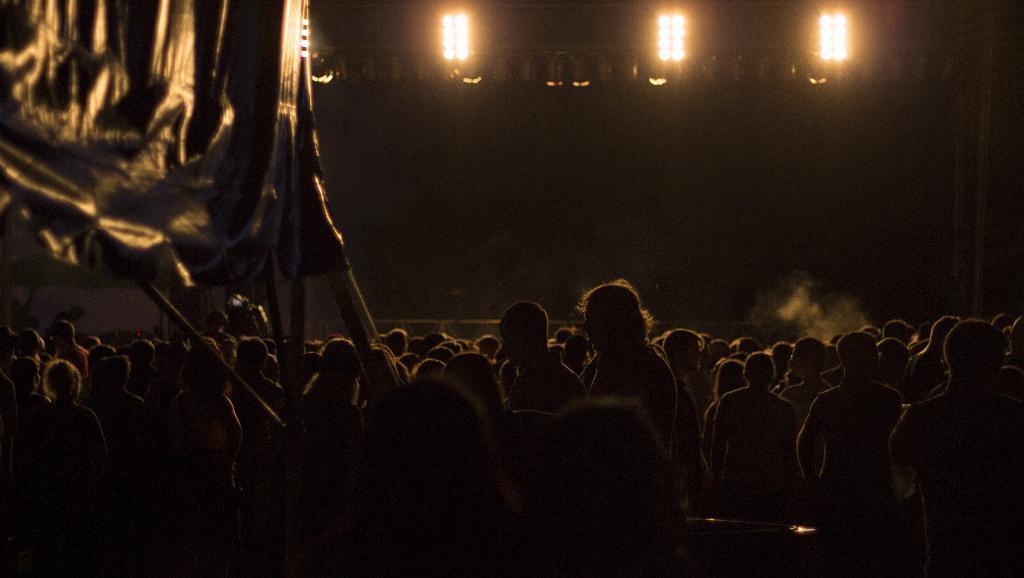Can you describe this image briefly? In this picture there are people at the bottom side of the image and there is a canvas in the top left side of the image, there are lights at the top side of the image. 